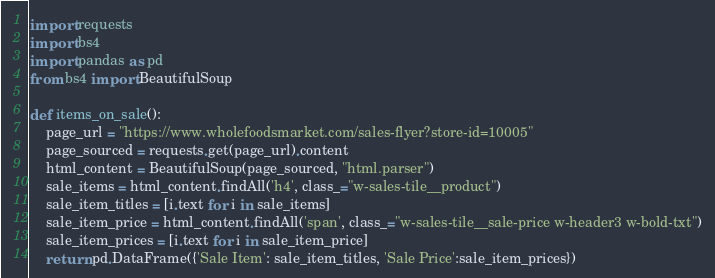Convert code to text. <code><loc_0><loc_0><loc_500><loc_500><_Python_>import requests
import bs4
import pandas as pd
from bs4 import BeautifulSoup

def items_on_sale():
    page_url = "https://www.wholefoodsmarket.com/sales-flyer?store-id=10005"
    page_sourced = requests.get(page_url).content
    html_content = BeautifulSoup(page_sourced, "html.parser")
    sale_items = html_content.findAll('h4', class_="w-sales-tile__product")
    sale_item_titles = [i.text for i in sale_items]
    sale_item_price = html_content.findAll('span', class_="w-sales-tile__sale-price w-header3 w-bold-txt")
    sale_item_prices = [i.text for i in sale_item_price]
    return pd.DataFrame({'Sale Item': sale_item_titles, 'Sale Price':sale_item_prices})</code> 